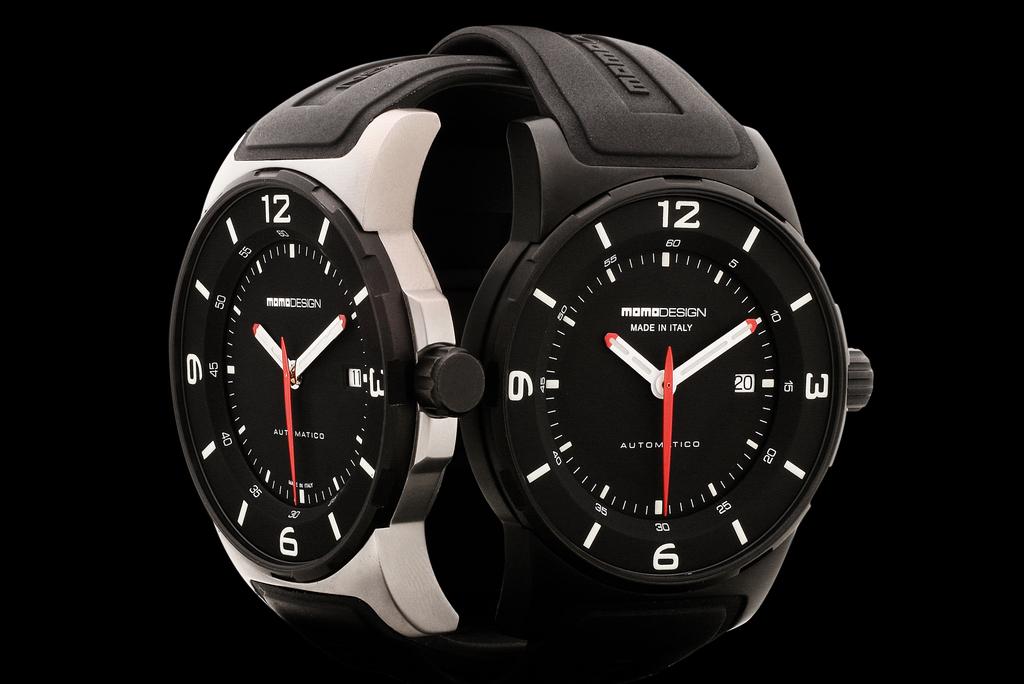What time do both watches say?
Offer a very short reply. 10:10. Where are these watches made?
Provide a short and direct response. Italy. 